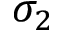<formula> <loc_0><loc_0><loc_500><loc_500>\sigma _ { 2 }</formula> 